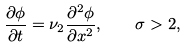<formula> <loc_0><loc_0><loc_500><loc_500>\frac { \partial \phi } { \partial t } = \nu _ { 2 } \frac { \partial ^ { 2 } \phi } { \partial x ^ { 2 } } , \quad \sigma > 2 ,</formula> 